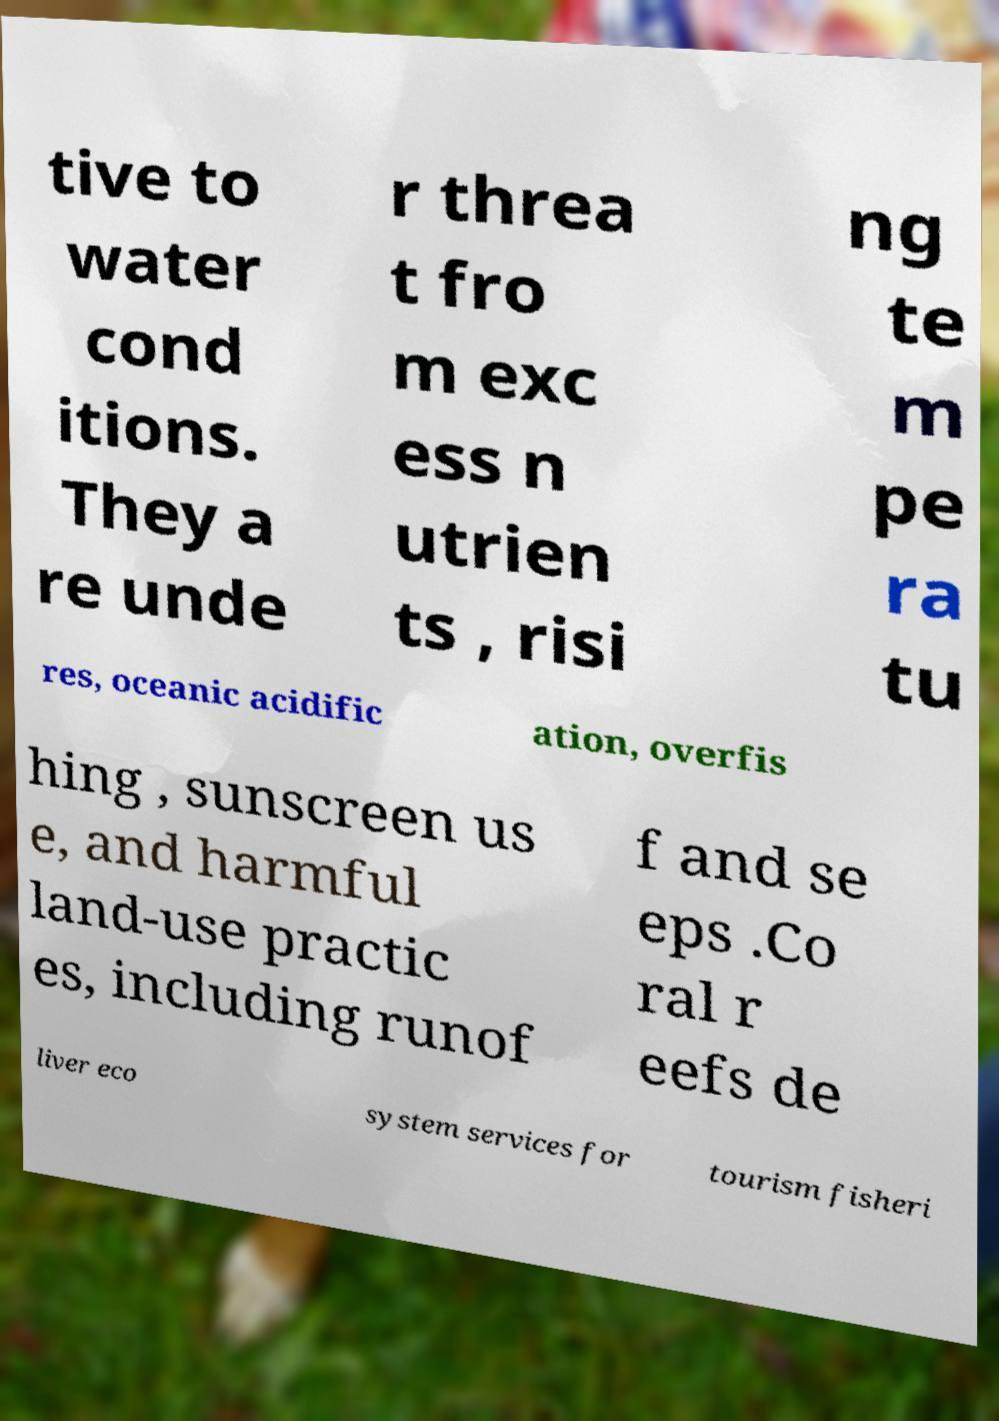For documentation purposes, I need the text within this image transcribed. Could you provide that? tive to water cond itions. They a re unde r threa t fro m exc ess n utrien ts , risi ng te m pe ra tu res, oceanic acidific ation, overfis hing , sunscreen us e, and harmful land-use practic es, including runof f and se eps .Co ral r eefs de liver eco system services for tourism fisheri 